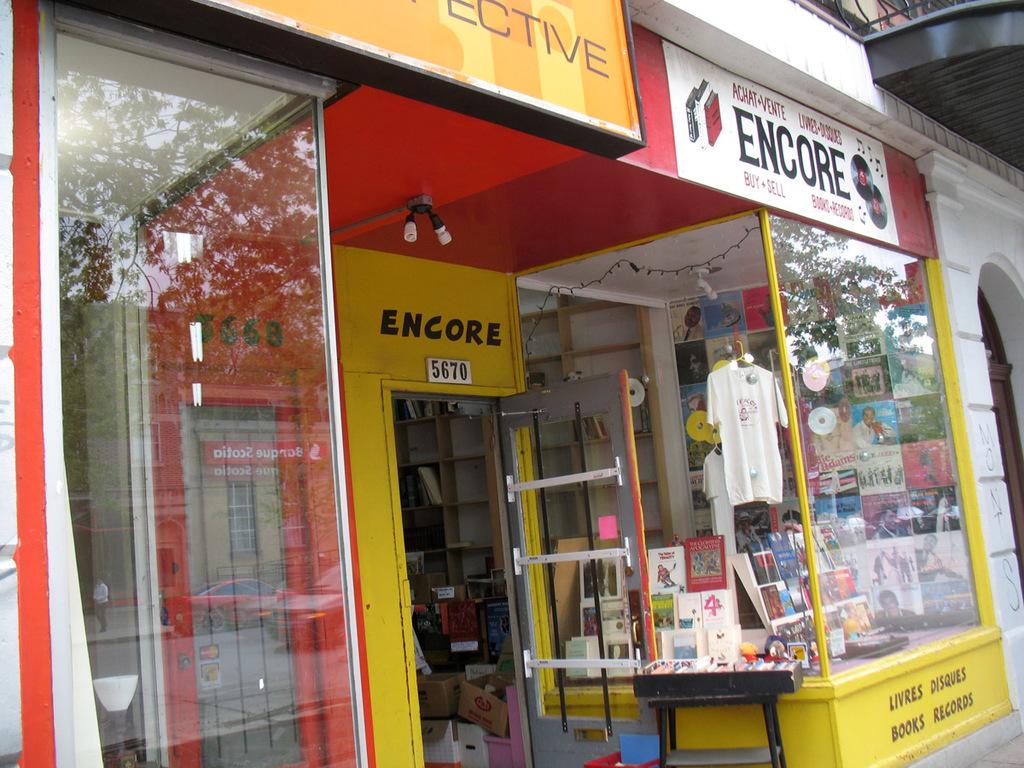What kind of store is encore?
Provide a short and direct response. Books and records. What is the number of encore?
Your response must be concise. 5670. 